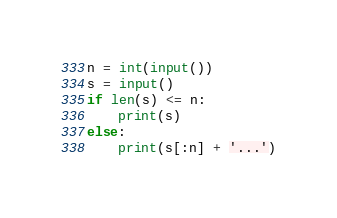Convert code to text. <code><loc_0><loc_0><loc_500><loc_500><_Python_>n = int(input())
s = input()
if len(s) <= n:
    print(s)
else:
    print(s[:n] + '...')
</code> 